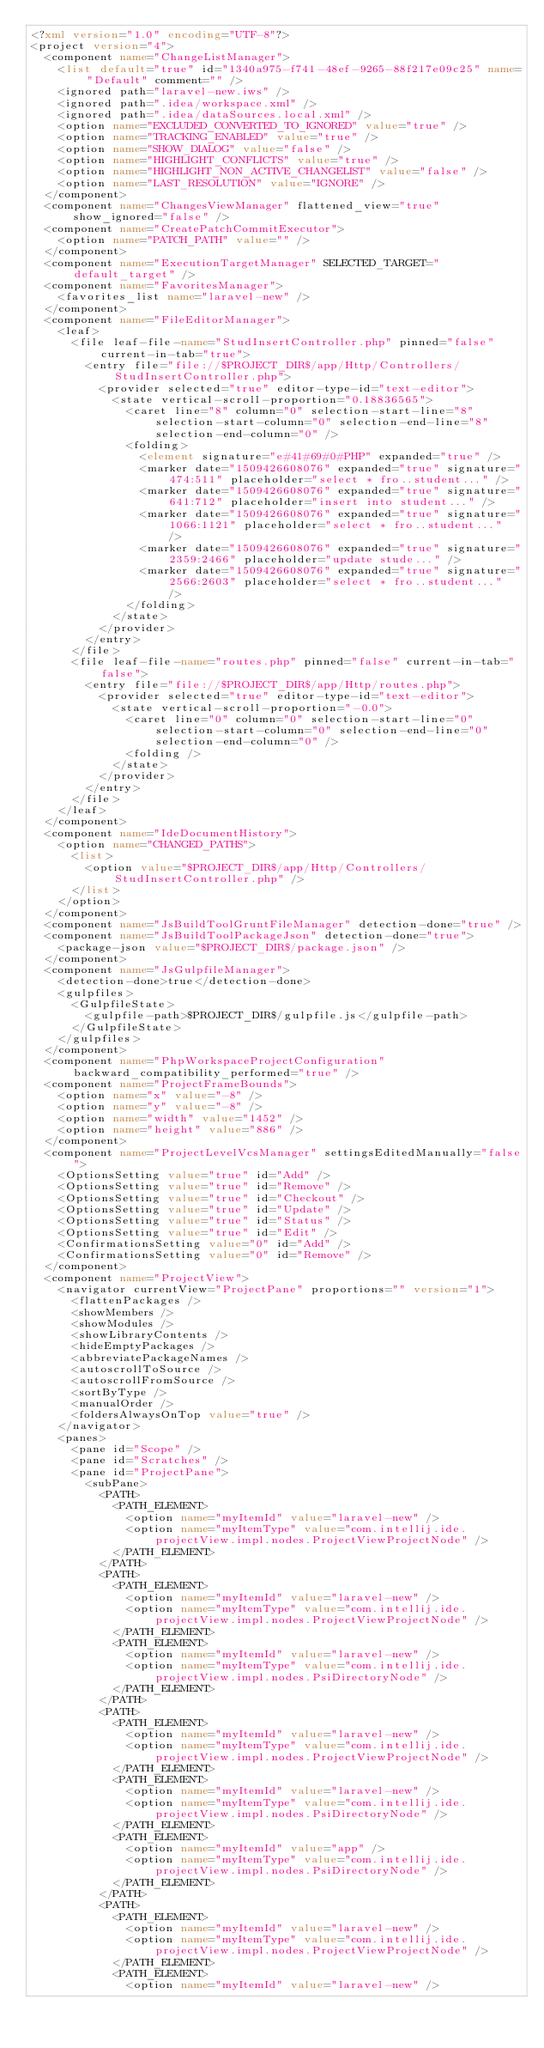Convert code to text. <code><loc_0><loc_0><loc_500><loc_500><_XML_><?xml version="1.0" encoding="UTF-8"?>
<project version="4">
  <component name="ChangeListManager">
    <list default="true" id="1340a975-f741-48ef-9265-88f217e09c25" name="Default" comment="" />
    <ignored path="laravel-new.iws" />
    <ignored path=".idea/workspace.xml" />
    <ignored path=".idea/dataSources.local.xml" />
    <option name="EXCLUDED_CONVERTED_TO_IGNORED" value="true" />
    <option name="TRACKING_ENABLED" value="true" />
    <option name="SHOW_DIALOG" value="false" />
    <option name="HIGHLIGHT_CONFLICTS" value="true" />
    <option name="HIGHLIGHT_NON_ACTIVE_CHANGELIST" value="false" />
    <option name="LAST_RESOLUTION" value="IGNORE" />
  </component>
  <component name="ChangesViewManager" flattened_view="true" show_ignored="false" />
  <component name="CreatePatchCommitExecutor">
    <option name="PATCH_PATH" value="" />
  </component>
  <component name="ExecutionTargetManager" SELECTED_TARGET="default_target" />
  <component name="FavoritesManager">
    <favorites_list name="laravel-new" />
  </component>
  <component name="FileEditorManager">
    <leaf>
      <file leaf-file-name="StudInsertController.php" pinned="false" current-in-tab="true">
        <entry file="file://$PROJECT_DIR$/app/Http/Controllers/StudInsertController.php">
          <provider selected="true" editor-type-id="text-editor">
            <state vertical-scroll-proportion="0.18836565">
              <caret line="8" column="0" selection-start-line="8" selection-start-column="0" selection-end-line="8" selection-end-column="0" />
              <folding>
                <element signature="e#41#69#0#PHP" expanded="true" />
                <marker date="1509426608076" expanded="true" signature="474:511" placeholder="select * fro..student..." />
                <marker date="1509426608076" expanded="true" signature="641:712" placeholder="insert into student..." />
                <marker date="1509426608076" expanded="true" signature="1066:1121" placeholder="select * fro..student..." />
                <marker date="1509426608076" expanded="true" signature="2359:2466" placeholder="update stude..." />
                <marker date="1509426608076" expanded="true" signature="2566:2603" placeholder="select * fro..student..." />
              </folding>
            </state>
          </provider>
        </entry>
      </file>
      <file leaf-file-name="routes.php" pinned="false" current-in-tab="false">
        <entry file="file://$PROJECT_DIR$/app/Http/routes.php">
          <provider selected="true" editor-type-id="text-editor">
            <state vertical-scroll-proportion="-0.0">
              <caret line="0" column="0" selection-start-line="0" selection-start-column="0" selection-end-line="0" selection-end-column="0" />
              <folding />
            </state>
          </provider>
        </entry>
      </file>
    </leaf>
  </component>
  <component name="IdeDocumentHistory">
    <option name="CHANGED_PATHS">
      <list>
        <option value="$PROJECT_DIR$/app/Http/Controllers/StudInsertController.php" />
      </list>
    </option>
  </component>
  <component name="JsBuildToolGruntFileManager" detection-done="true" />
  <component name="JsBuildToolPackageJson" detection-done="true">
    <package-json value="$PROJECT_DIR$/package.json" />
  </component>
  <component name="JsGulpfileManager">
    <detection-done>true</detection-done>
    <gulpfiles>
      <GulpfileState>
        <gulpfile-path>$PROJECT_DIR$/gulpfile.js</gulpfile-path>
      </GulpfileState>
    </gulpfiles>
  </component>
  <component name="PhpWorkspaceProjectConfiguration" backward_compatibility_performed="true" />
  <component name="ProjectFrameBounds">
    <option name="x" value="-8" />
    <option name="y" value="-8" />
    <option name="width" value="1452" />
    <option name="height" value="886" />
  </component>
  <component name="ProjectLevelVcsManager" settingsEditedManually="false">
    <OptionsSetting value="true" id="Add" />
    <OptionsSetting value="true" id="Remove" />
    <OptionsSetting value="true" id="Checkout" />
    <OptionsSetting value="true" id="Update" />
    <OptionsSetting value="true" id="Status" />
    <OptionsSetting value="true" id="Edit" />
    <ConfirmationsSetting value="0" id="Add" />
    <ConfirmationsSetting value="0" id="Remove" />
  </component>
  <component name="ProjectView">
    <navigator currentView="ProjectPane" proportions="" version="1">
      <flattenPackages />
      <showMembers />
      <showModules />
      <showLibraryContents />
      <hideEmptyPackages />
      <abbreviatePackageNames />
      <autoscrollToSource />
      <autoscrollFromSource />
      <sortByType />
      <manualOrder />
      <foldersAlwaysOnTop value="true" />
    </navigator>
    <panes>
      <pane id="Scope" />
      <pane id="Scratches" />
      <pane id="ProjectPane">
        <subPane>
          <PATH>
            <PATH_ELEMENT>
              <option name="myItemId" value="laravel-new" />
              <option name="myItemType" value="com.intellij.ide.projectView.impl.nodes.ProjectViewProjectNode" />
            </PATH_ELEMENT>
          </PATH>
          <PATH>
            <PATH_ELEMENT>
              <option name="myItemId" value="laravel-new" />
              <option name="myItemType" value="com.intellij.ide.projectView.impl.nodes.ProjectViewProjectNode" />
            </PATH_ELEMENT>
            <PATH_ELEMENT>
              <option name="myItemId" value="laravel-new" />
              <option name="myItemType" value="com.intellij.ide.projectView.impl.nodes.PsiDirectoryNode" />
            </PATH_ELEMENT>
          </PATH>
          <PATH>
            <PATH_ELEMENT>
              <option name="myItemId" value="laravel-new" />
              <option name="myItemType" value="com.intellij.ide.projectView.impl.nodes.ProjectViewProjectNode" />
            </PATH_ELEMENT>
            <PATH_ELEMENT>
              <option name="myItemId" value="laravel-new" />
              <option name="myItemType" value="com.intellij.ide.projectView.impl.nodes.PsiDirectoryNode" />
            </PATH_ELEMENT>
            <PATH_ELEMENT>
              <option name="myItemId" value="app" />
              <option name="myItemType" value="com.intellij.ide.projectView.impl.nodes.PsiDirectoryNode" />
            </PATH_ELEMENT>
          </PATH>
          <PATH>
            <PATH_ELEMENT>
              <option name="myItemId" value="laravel-new" />
              <option name="myItemType" value="com.intellij.ide.projectView.impl.nodes.ProjectViewProjectNode" />
            </PATH_ELEMENT>
            <PATH_ELEMENT>
              <option name="myItemId" value="laravel-new" /></code> 